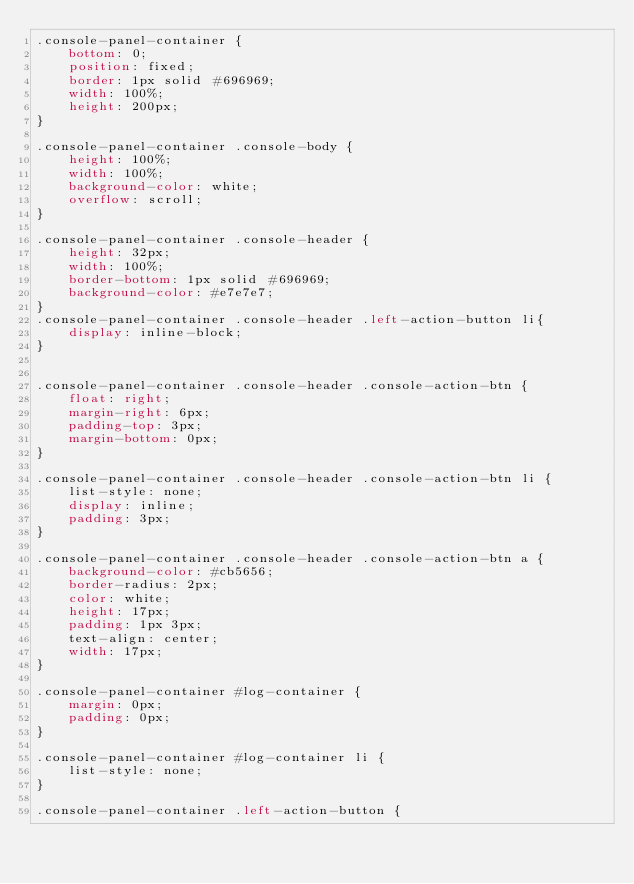<code> <loc_0><loc_0><loc_500><loc_500><_CSS_>.console-panel-container {
    bottom: 0;
    position: fixed;
    border: 1px solid #696969;
    width: 100%;
    height: 200px;
}

.console-panel-container .console-body {
    height: 100%;
    width: 100%;
    background-color: white;
    overflow: scroll;
}

.console-panel-container .console-header {
    height: 32px;
    width: 100%;
    border-bottom: 1px solid #696969;
    background-color: #e7e7e7;
}
.console-panel-container .console-header .left-action-button li{
    display: inline-block;
}


.console-panel-container .console-header .console-action-btn {
    float: right;
    margin-right: 6px;
    padding-top: 3px;
    margin-bottom: 0px;
}

.console-panel-container .console-header .console-action-btn li {
    list-style: none;
    display: inline;
    padding: 3px;
}

.console-panel-container .console-header .console-action-btn a {
    background-color: #cb5656;
    border-radius: 2px;
    color: white;
    height: 17px;
    padding: 1px 3px;
    text-align: center;
    width: 17px;
}

.console-panel-container #log-container {
    margin: 0px;
    padding: 0px;
}

.console-panel-container #log-container li {
    list-style: none;
}

.console-panel-container .left-action-button {</code> 